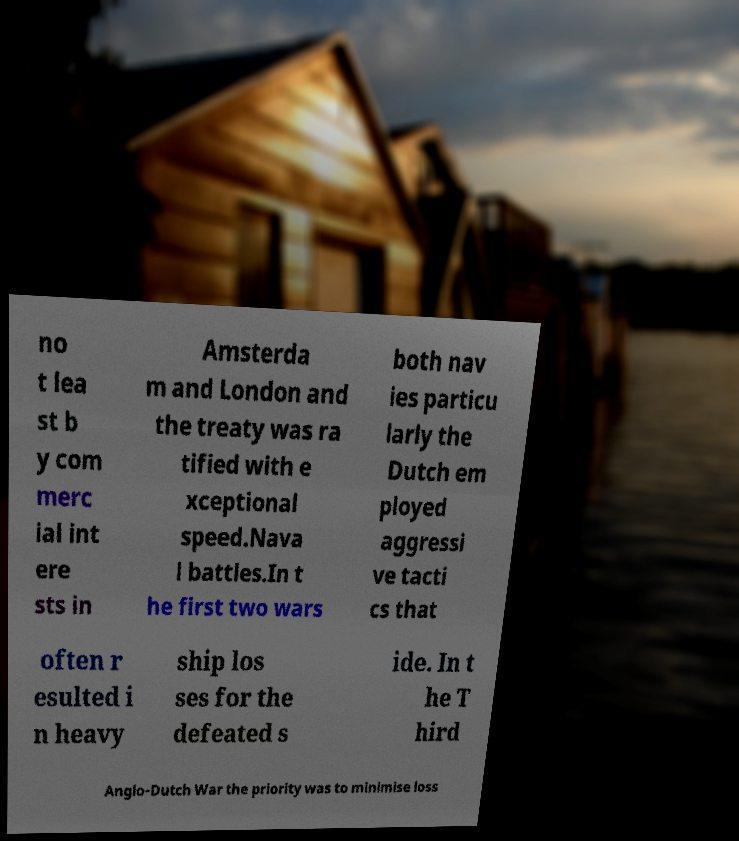I need the written content from this picture converted into text. Can you do that? no t lea st b y com merc ial int ere sts in Amsterda m and London and the treaty was ra tified with e xceptional speed.Nava l battles.In t he first two wars both nav ies particu larly the Dutch em ployed aggressi ve tacti cs that often r esulted i n heavy ship los ses for the defeated s ide. In t he T hird Anglo-Dutch War the priority was to minimise loss 